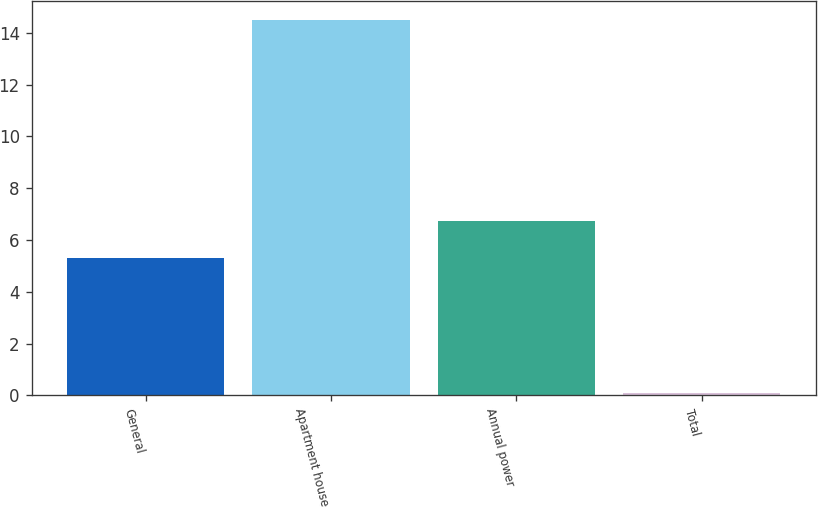Convert chart to OTSL. <chart><loc_0><loc_0><loc_500><loc_500><bar_chart><fcel>General<fcel>Apartment house<fcel>Annual power<fcel>Total<nl><fcel>5.3<fcel>14.5<fcel>6.74<fcel>0.1<nl></chart> 